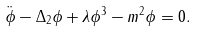Convert formula to latex. <formula><loc_0><loc_0><loc_500><loc_500>\ddot { \phi } - \Delta _ { 2 } \phi + \lambda \phi ^ { 3 } - m ^ { 2 } \phi = 0 .</formula> 